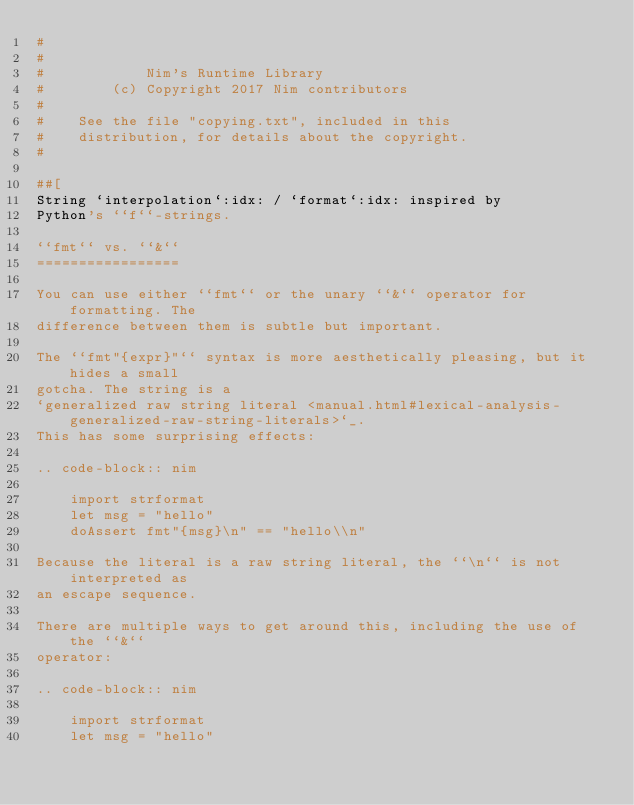<code> <loc_0><loc_0><loc_500><loc_500><_Nim_>#
#
#            Nim's Runtime Library
#        (c) Copyright 2017 Nim contributors
#
#    See the file "copying.txt", included in this
#    distribution, for details about the copyright.
#

##[
String `interpolation`:idx: / `format`:idx: inspired by
Python's ``f``-strings.

``fmt`` vs. ``&``
=================

You can use either ``fmt`` or the unary ``&`` operator for formatting. The
difference between them is subtle but important.

The ``fmt"{expr}"`` syntax is more aesthetically pleasing, but it hides a small
gotcha. The string is a
`generalized raw string literal <manual.html#lexical-analysis-generalized-raw-string-literals>`_.
This has some surprising effects:

.. code-block:: nim

    import strformat
    let msg = "hello"
    doAssert fmt"{msg}\n" == "hello\\n"

Because the literal is a raw string literal, the ``\n`` is not interpreted as
an escape sequence.

There are multiple ways to get around this, including the use of the ``&``
operator:

.. code-block:: nim

    import strformat
    let msg = "hello"
</code> 